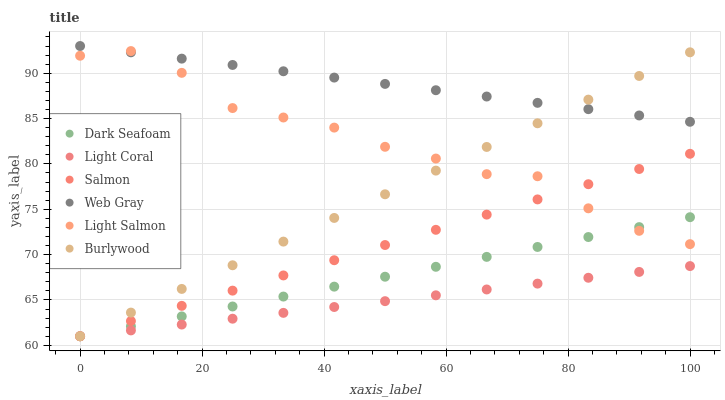Does Light Coral have the minimum area under the curve?
Answer yes or no. Yes. Does Web Gray have the maximum area under the curve?
Answer yes or no. Yes. Does Burlywood have the minimum area under the curve?
Answer yes or no. No. Does Burlywood have the maximum area under the curve?
Answer yes or no. No. Is Web Gray the smoothest?
Answer yes or no. Yes. Is Light Salmon the roughest?
Answer yes or no. Yes. Is Burlywood the smoothest?
Answer yes or no. No. Is Burlywood the roughest?
Answer yes or no. No. Does Burlywood have the lowest value?
Answer yes or no. Yes. Does Web Gray have the lowest value?
Answer yes or no. No. Does Web Gray have the highest value?
Answer yes or no. Yes. Does Burlywood have the highest value?
Answer yes or no. No. Is Light Coral less than Web Gray?
Answer yes or no. Yes. Is Web Gray greater than Dark Seafoam?
Answer yes or no. Yes. Does Burlywood intersect Salmon?
Answer yes or no. Yes. Is Burlywood less than Salmon?
Answer yes or no. No. Is Burlywood greater than Salmon?
Answer yes or no. No. Does Light Coral intersect Web Gray?
Answer yes or no. No. 